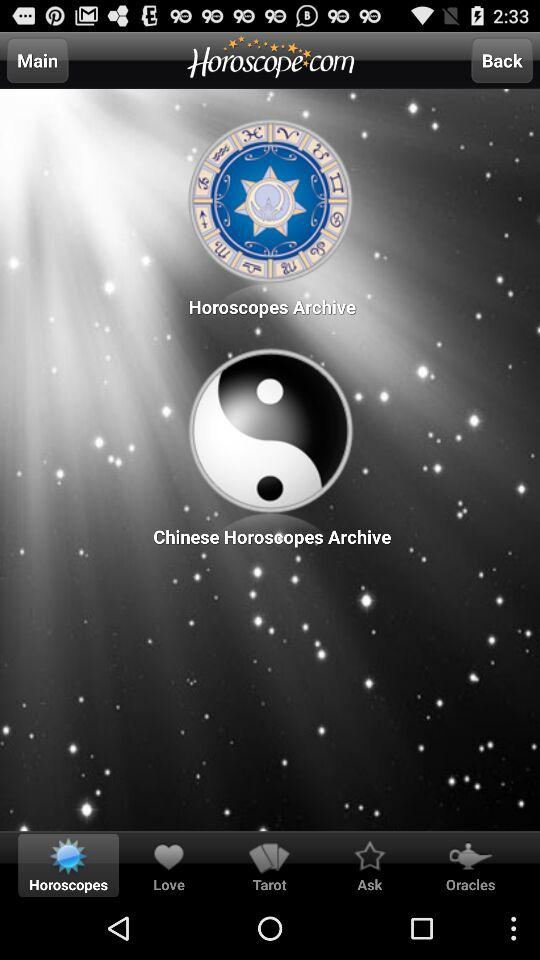What is the name of the application? The name of the application is "Horoscope.com". 